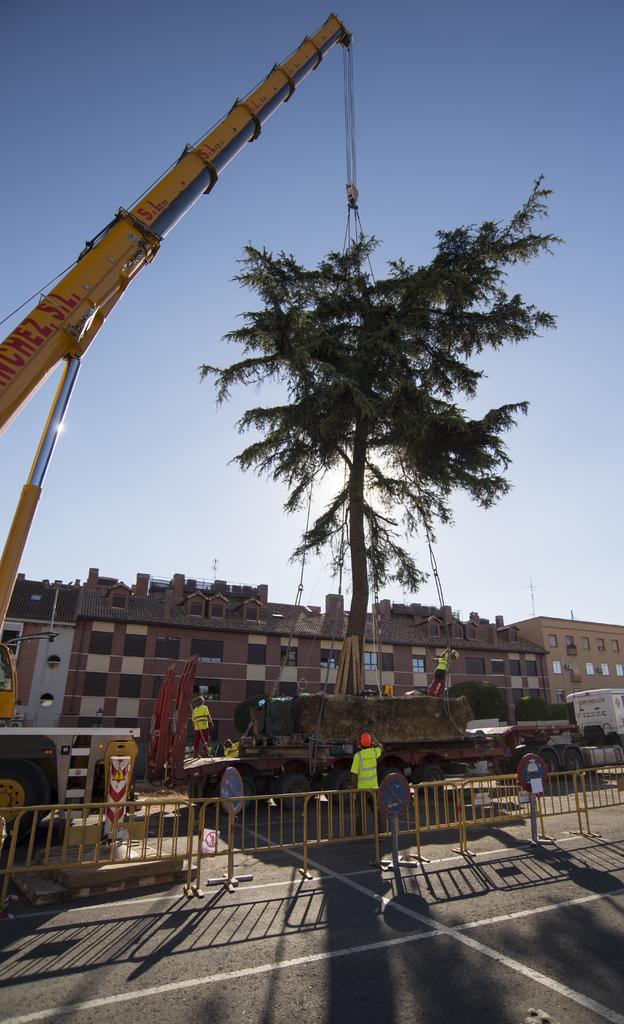In one or two sentences, can you explain what this image depicts? In this picture I can see the road at the bottom, there is a crane on the left side. I can see few persons in the middle and there is a tree, in the background there are buildings. At the top there is the sky. 